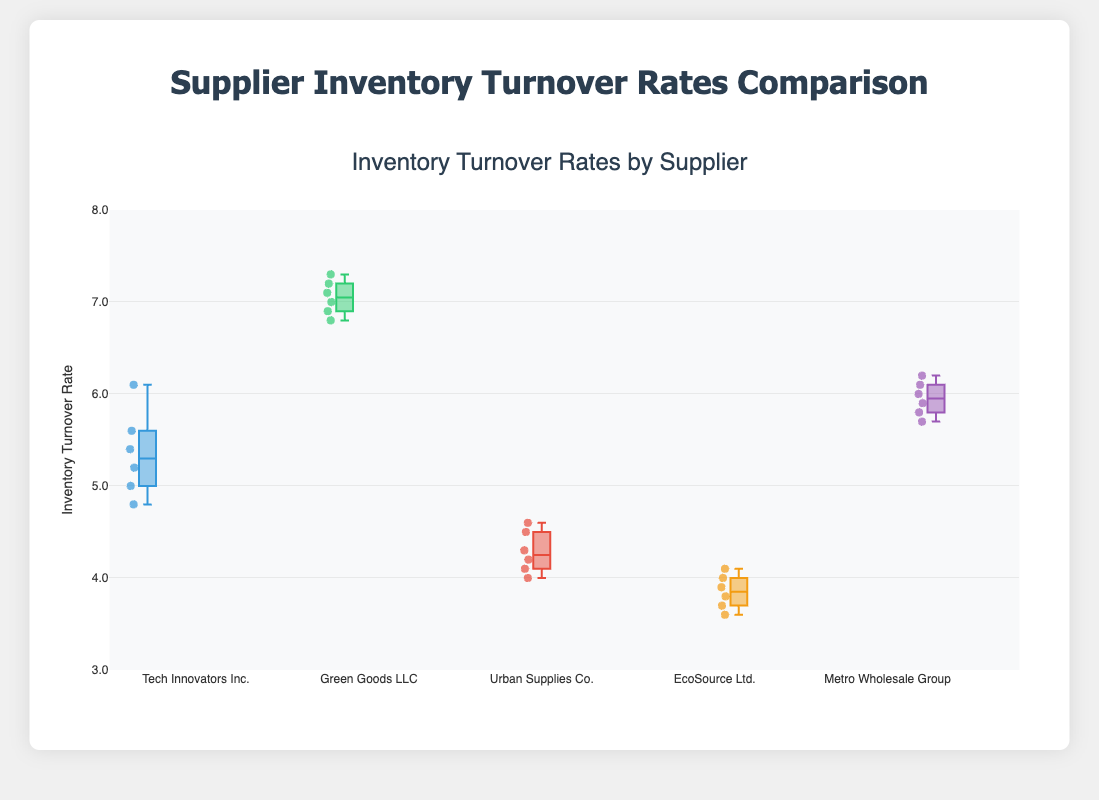What is the median inventory turnover rate for Tech Innovators Inc.? To find the median, arrange the turnover rates in ascending order [4.8, 5.0, 5.2, 5.4, 5.6, 6.1]. Since there are 6 values, the median is the average of the 3rd and 4th values. So the median is (5.2 + 5.4) / 2 = 5.3.
Answer: 5.3 Which supplier has the highest median turnover rate? To determine this, look at the medians of each supplier. For Green Goods LLC, the turnover rates are [6.8, 6.9, 7.0, 7.1, 7.2, 7.3], so the median is (7.0 + 7.1) / 2 = 7.05. Performing similar calculations for the other suppliers, Green Goods LLC has the highest median.
Answer: Green Goods LLC What is the interquartile range (IQR) for Urban Supplies Co.? The IQR is the difference between the 75th percentile (Q3) and the 25th percentile (Q1) values. For Urban Supplies Co., the ordered rates are [4.0, 4.1, 4.2, 4.3, 4.5, 4.6]. Q1 (25th percentile) is (4.1 + 4.2) / 2 = 4.15 and Q3 (75th percentile) is (4.3 + 4.5) / 2 = 4.4. Hence, IQR = 4.4 - 4.15 = 0.25.
Answer: 0.25 Which supplier has the most consistent turnover rates? Consistency can be determined by the spread of values. EcoSource Ltd. has the inventory rates [3.6, 3.7, 3.8, 3.9, 4.0, 4.1], which displays less variation and spread compared to others. This is evident from its narrower box and whiskers.
Answer: EcoSource Ltd How does the maximum turnover rate of Metro Wholesale Group compare with Green Goods LLC? The maximum turnover rate for Green Goods LLC is 7.3, while for Metro Wholesale Group it is 6.2. Thus, Green Goods LLC has a higher maximum turnover rate by 1.1 units.
Answer: Green Goods LLC is higher by 1.1 units Which supplier shows the widest range of inventory turnover rates? The range is determined by the difference between the maximum and minimum values for each supplier. Green Goods LLC has rates from 6.8 to 7.3, giving a range of 0.5. Other ranges: Tech Innovators Inc. (6.1 - 4.8 = 1.3), Urban Supplies Co. (4.6 - 4.0 = 0.6), EcoSource Ltd. (4.1 - 3.6 = 0.5), Metro Wholesale Group (6.2 - 5.7 = 0.5). Therefore, Tech Innovators Inc. has the widest range.
Answer: Tech Innovators Inc What is the difference between the median turnover rates of Urban Supplies Co. and EcoSource Ltd.? Calculate the median for Urban Supplies Co. and EcoSource Ltd. Urban Supplies Co. rates are [4.0, 4.1, 4.2, 4.3, 4.5, 4.6] so the median is (4.2 + 4.3)/2 = 4.25. EcoSource Ltd. rates are [3.6, 3.7, 3.8, 3.9, 4.0, 4.1] so the median is (3.8 + 3.9)/2 = 3.85. Thus, the difference is 4.25 - 3.85 = 0.4.
Answer: 0.4 How many data points are being compared for each supplier? Each supplier has an array of 6 turnover rate data points visible on the box plot.
Answer: 6 Which supplier has the highest minimum turnover rate? Compare the minimum values across the suppliers. Green Goods LLC has a minimum of 6.8, which is the highest among all.
Answer: Green Goods LLC Are there any outliers in the turnover rates for any suppliers? Outliers are typically marked as individual points outside the whiskers. From the box plot provided, there are no individual points that suggest outliers.
Answer: No 